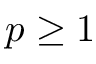Convert formula to latex. <formula><loc_0><loc_0><loc_500><loc_500>p \geq 1</formula> 